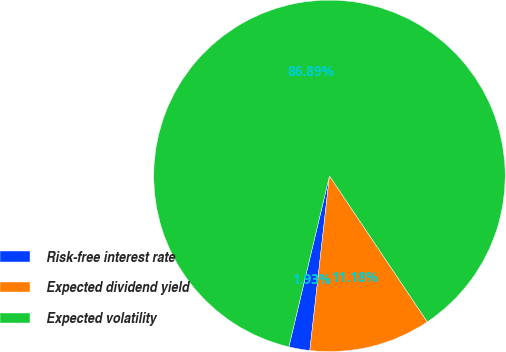Convert chart to OTSL. <chart><loc_0><loc_0><loc_500><loc_500><pie_chart><fcel>Risk-free interest rate<fcel>Expected dividend yield<fcel>Expected volatility<nl><fcel>1.93%<fcel>11.18%<fcel>86.88%<nl></chart> 